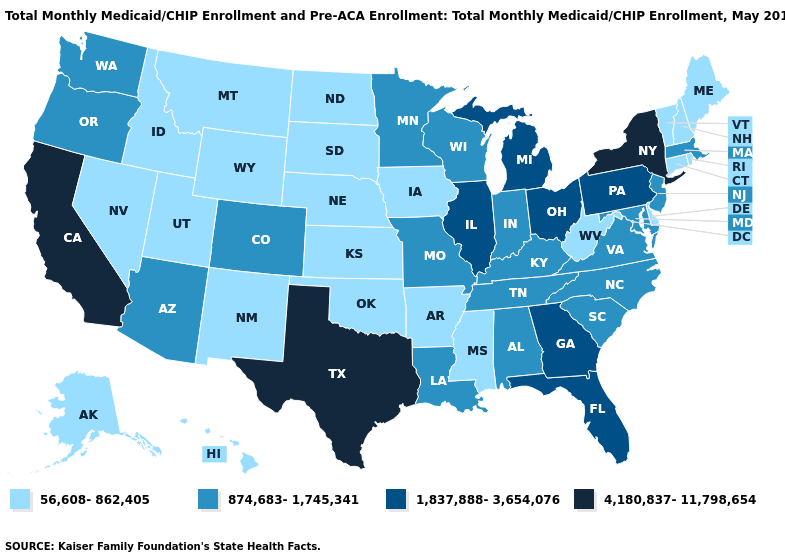Which states have the lowest value in the Northeast?
Concise answer only. Connecticut, Maine, New Hampshire, Rhode Island, Vermont. Does Colorado have the lowest value in the USA?
Be succinct. No. Among the states that border Georgia , does Tennessee have the highest value?
Quick response, please. No. What is the value of Oregon?
Answer briefly. 874,683-1,745,341. Does Michigan have a higher value than Illinois?
Be succinct. No. Which states have the highest value in the USA?
Quick response, please. California, New York, Texas. Name the states that have a value in the range 56,608-862,405?
Be succinct. Alaska, Arkansas, Connecticut, Delaware, Hawaii, Idaho, Iowa, Kansas, Maine, Mississippi, Montana, Nebraska, Nevada, New Hampshire, New Mexico, North Dakota, Oklahoma, Rhode Island, South Dakota, Utah, Vermont, West Virginia, Wyoming. Which states hav the highest value in the Northeast?
Concise answer only. New York. Does Nevada have the same value as New Mexico?
Give a very brief answer. Yes. Which states have the lowest value in the USA?
Give a very brief answer. Alaska, Arkansas, Connecticut, Delaware, Hawaii, Idaho, Iowa, Kansas, Maine, Mississippi, Montana, Nebraska, Nevada, New Hampshire, New Mexico, North Dakota, Oklahoma, Rhode Island, South Dakota, Utah, Vermont, West Virginia, Wyoming. What is the value of New Mexico?
Answer briefly. 56,608-862,405. Among the states that border Nebraska , does Missouri have the highest value?
Quick response, please. Yes. What is the lowest value in states that border Colorado?
Write a very short answer. 56,608-862,405. Name the states that have a value in the range 1,837,888-3,654,076?
Be succinct. Florida, Georgia, Illinois, Michigan, Ohio, Pennsylvania. What is the value of Michigan?
Short answer required. 1,837,888-3,654,076. 